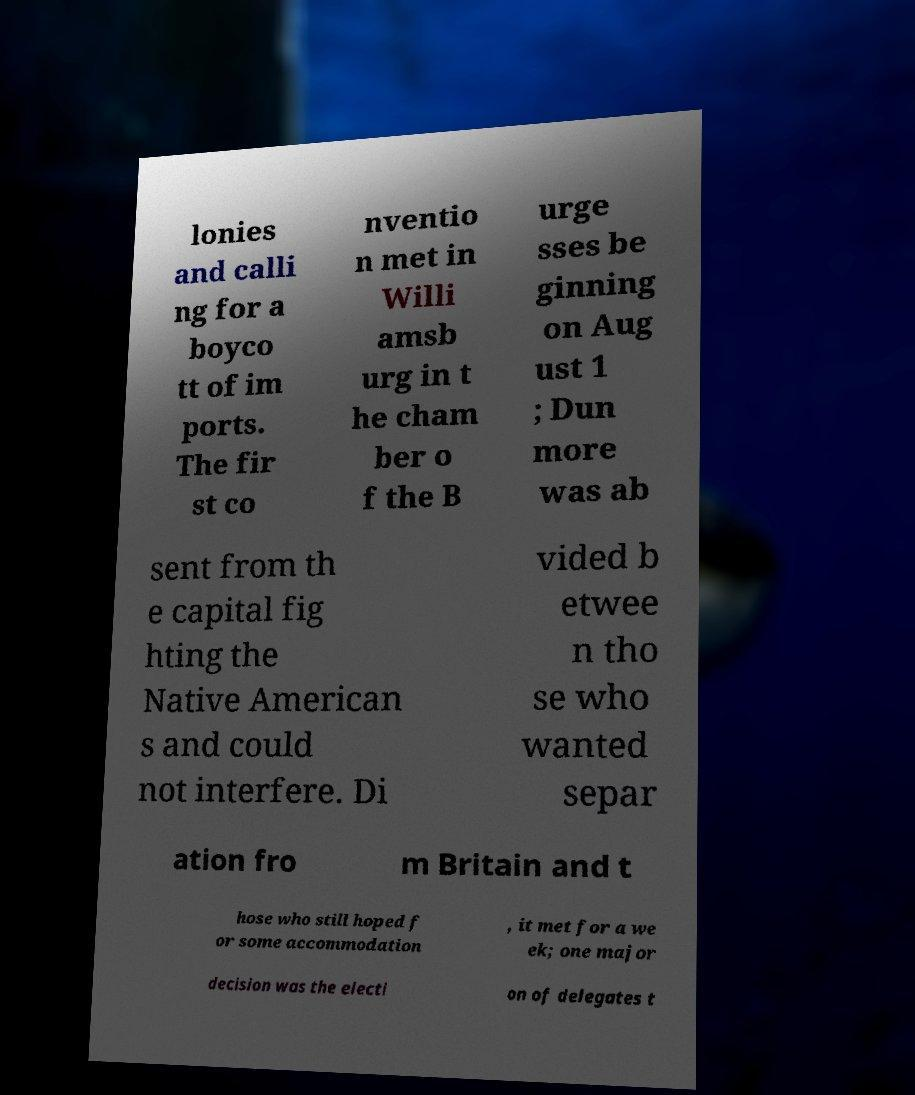What messages or text are displayed in this image? I need them in a readable, typed format. lonies and calli ng for a boyco tt of im ports. The fir st co nventio n met in Willi amsb urg in t he cham ber o f the B urge sses be ginning on Aug ust 1 ; Dun more was ab sent from th e capital fig hting the Native American s and could not interfere. Di vided b etwee n tho se who wanted separ ation fro m Britain and t hose who still hoped f or some accommodation , it met for a we ek; one major decision was the electi on of delegates t 